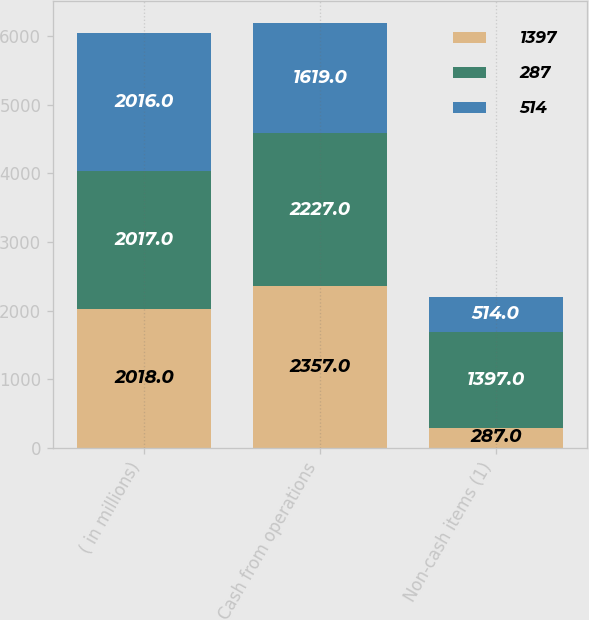Convert chart to OTSL. <chart><loc_0><loc_0><loc_500><loc_500><stacked_bar_chart><ecel><fcel>( in millions)<fcel>Cash from operations<fcel>Non-cash items (1)<nl><fcel>1397<fcel>2018<fcel>2357<fcel>287<nl><fcel>287<fcel>2017<fcel>2227<fcel>1397<nl><fcel>514<fcel>2016<fcel>1619<fcel>514<nl></chart> 